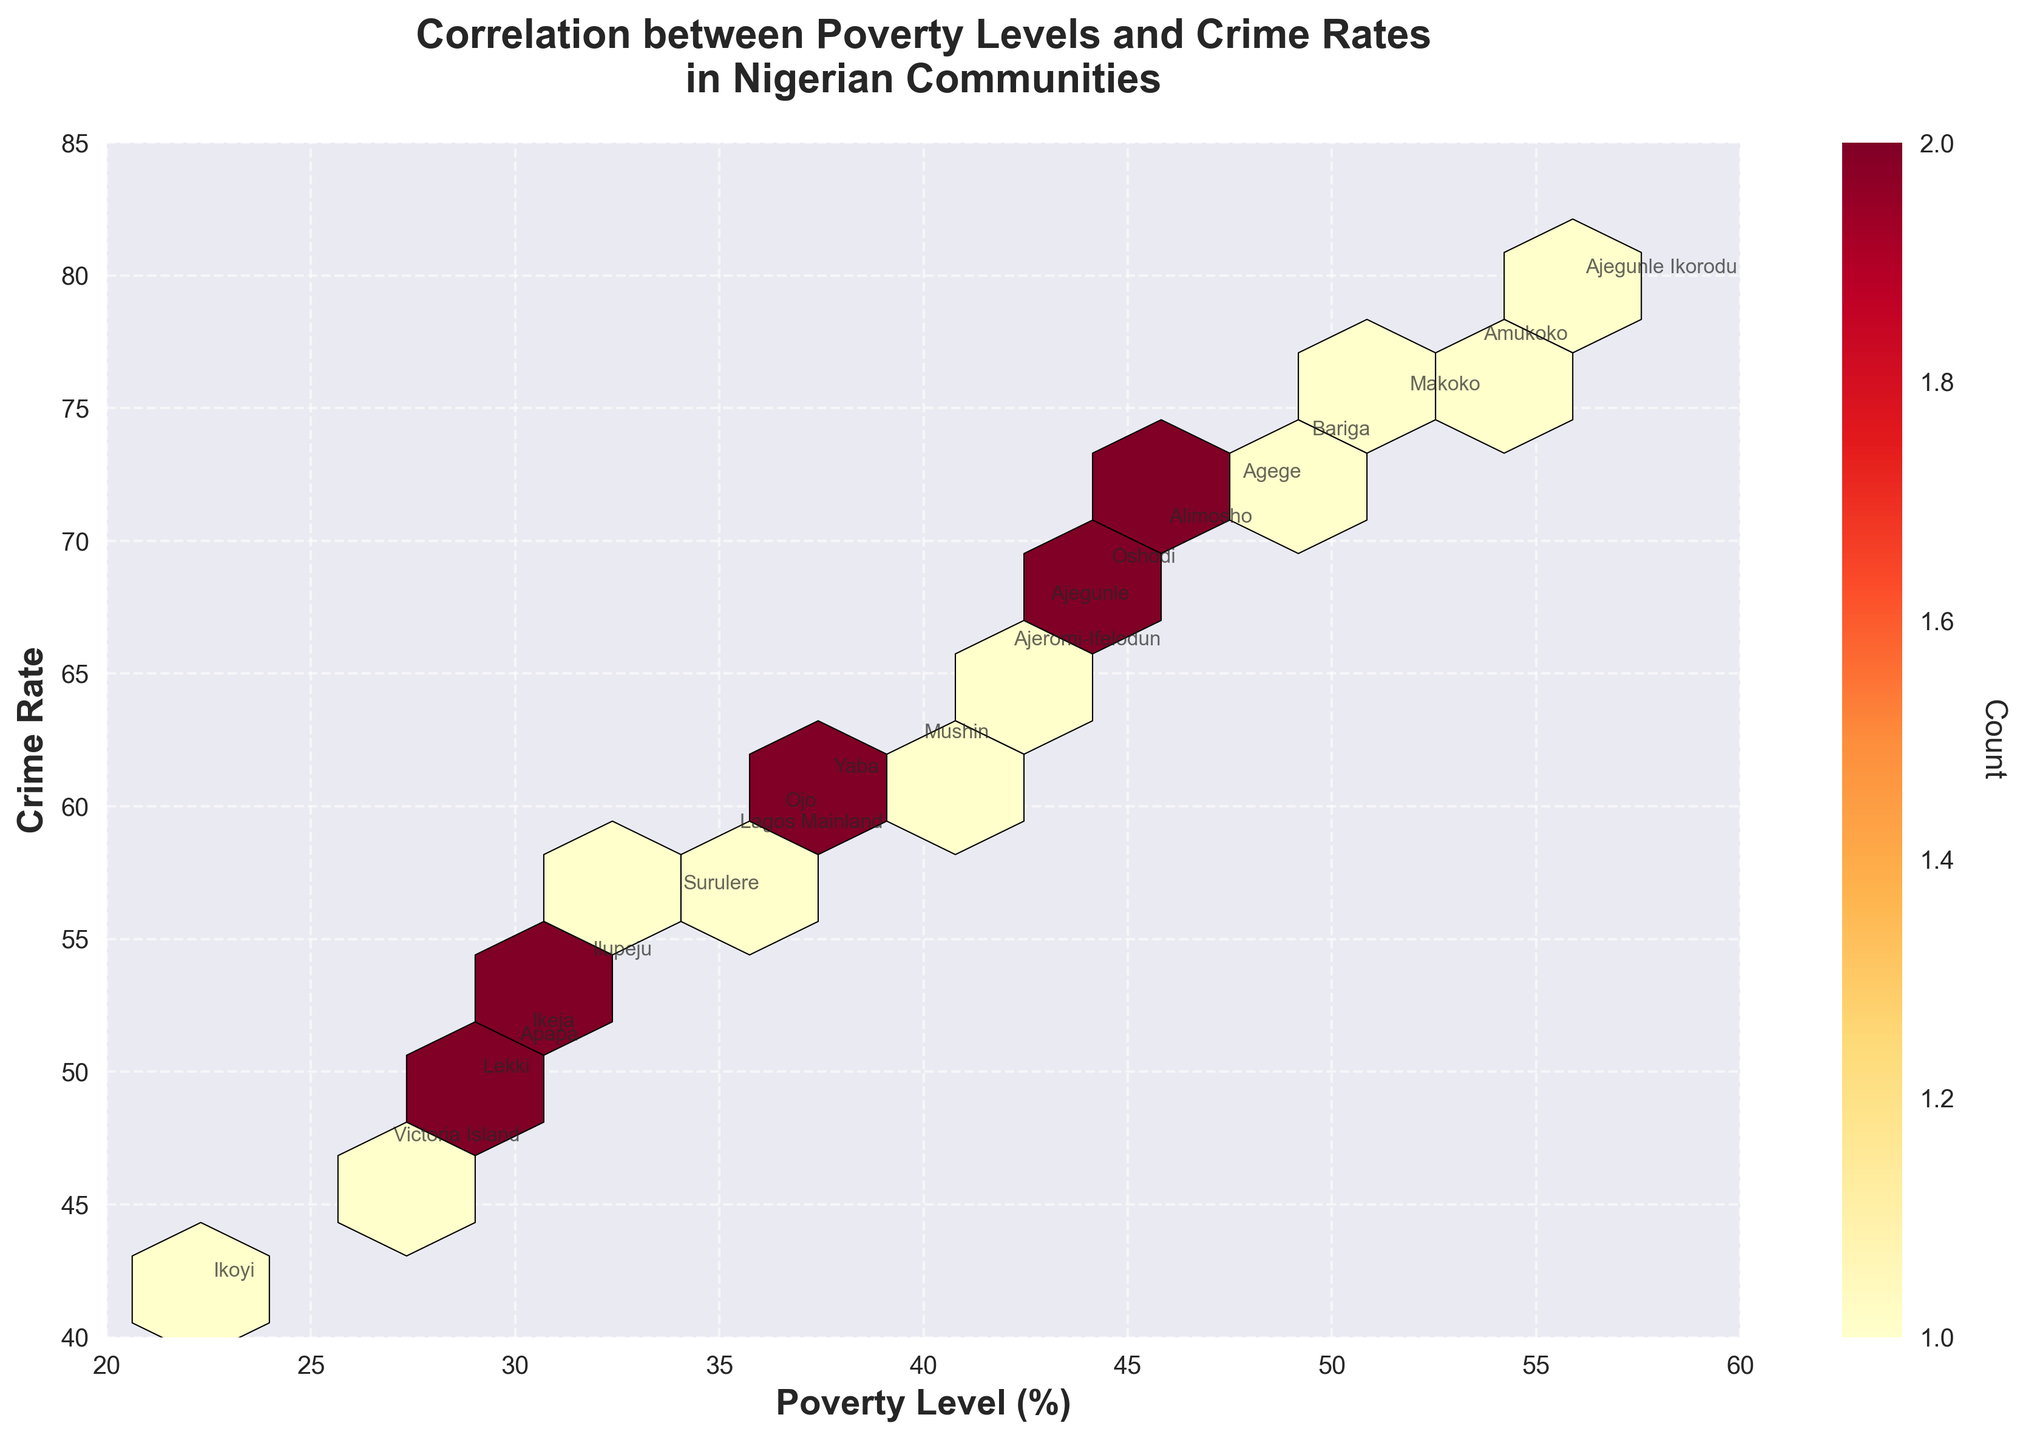What is the title of the figure? The title of the figure is located at the top center of the plot and summarizes what the figure represents. In this case, it reads "Correlation between Poverty Levels and Crime Rates in Nigerian Communities".
Answer: Correlation between Poverty Levels and Crime Rates in Nigerian Communities What do the x and y axes represent? The x-axis is labeled "Poverty Level (%)" which represents the percentage of poverty level in the community. The y-axis is labeled "Crime Rate" which represents the crime rate in the community.
Answer: Poverty Level (%) and Crime Rate How many data points (communities) are displayed in the figure? By looking at the annotations and individual points marked with community names, we can count the number of unique data points shown in the figure. Each community is annotated, so it's clear there are 20 data points.
Answer: 20 Which community has the highest poverty level and what is its corresponding crime rate? The community with the highest poverty level can be found by identifying the furthest point to the right on the x-axis of the plot. Ajegunle Ikorodu has the highest poverty level at 55.9%, and its corresponding crime rate is 79.6.
Answer: Ajegunle Ikorodu, 79.6 What is the relationship between poverty levels and crime rates as depicted in the plot? The trend shown by color density and the general distribution pattern in the figure indicates a positive correlation. As the poverty level increases (moving right on the x-axis), the crime rate tends to increase as well (moving up on the y-axis).
Answer: Positive correlation Between 'Oshodi' and 'Ikoyi', which community has a higher crime rate, and by how much? By locating the points and annotations for 'Oshodi' and 'Ikoyi', the y-axis values can be compared. Oshodi has a crime rate of 68.7, while Ikoyi has a crime rate of 41.8. The difference in their crime rates is 68.7 - 41.8 = 26.9.
Answer: Oshodi, 26.9 What color indicates the highest density of data points in the hexbin plot? The color bar to the right of the plot shows the count of data points in each hexagon. The color that represents the highest count of data points is on the darker end of the 'YlOrRd' color scale used, which is dark red.
Answer: Dark red Is there any community with crime rates lower than 45? Name it if there is. By examining the y-axis and annotations, we look for any point below the 45 mark on the y-axis. Ikoyi has a crime rate of 41.8, which is below 45.
Answer: Ikoyi Are there any communities with poverty levels below 30%? If so, list them along with their corresponding crime rates. By checking the poverty levels on the x-axis, we identify points to the left of the 30% mark. The communities are:
- Ikoyi: 41.8
- Lekki: 49.5
- Victoria Island: 46.9
- Apapa: 50.7
Answer: Ikoyi: 41.8, Lekki: 49.5, Victoria Island: 46.9, Apapa: 50.7 